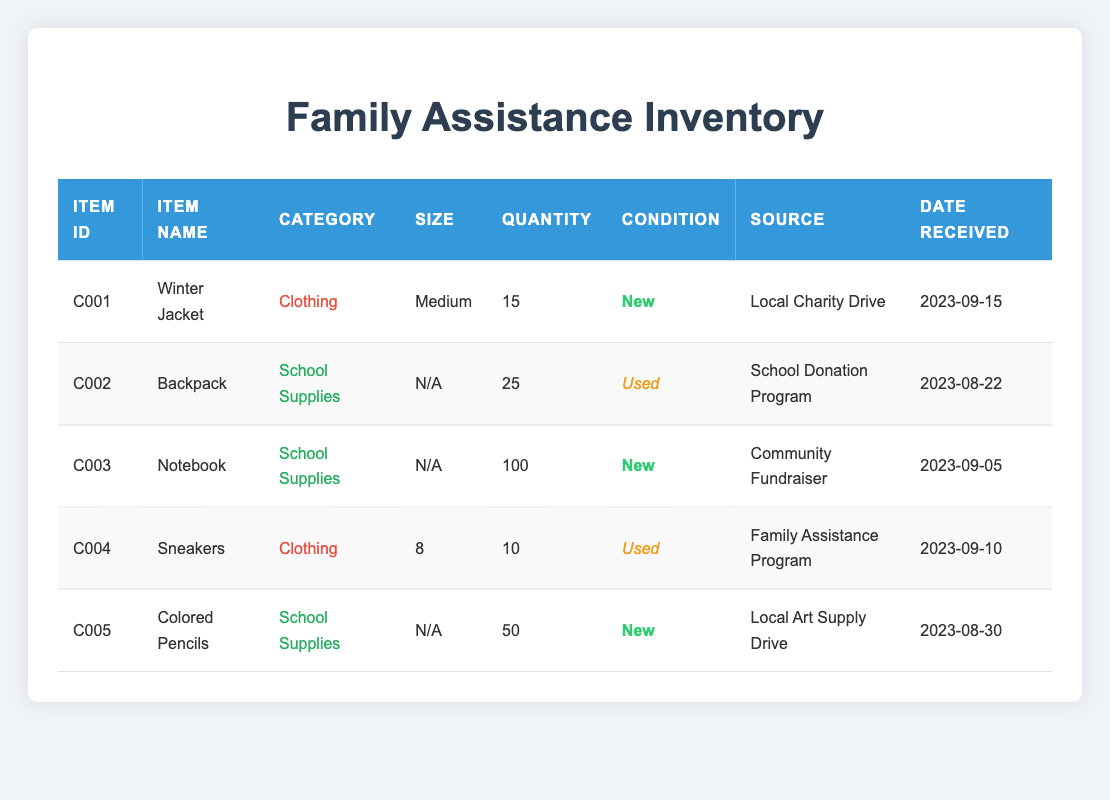What is the quantity of Winter Jackets received? The table lists the item 'Winter Jacket' with an item ID of C001, and in the quantity column for this item, it shows '15'.
Answer: 15 How many used items are in the inventory? The inventory contains two used items: 'Backpack' (C002) with a quantity of 25 and 'Sneakers' (C004) with a quantity of 10. Therefore, the total used items is 25 + 10 = 35.
Answer: 35 Which item has the largest quantity? By looking at the quantities listed, 'Notebook' (C003) has the highest quantity at 100. Thus, the item with the largest quantity is 'Notebook'.
Answer: Notebook Are there any items in good condition received from the Family Assistance Program? The 'Sneakers' (C004) is the only item listed from the 'Family Assistance Program', and it is marked as 'Used', which is not in good condition. Therefore, there are no items in good condition from this source.
Answer: No What is the total quantity of school supplies received? The school supplies in the inventory include 'Backpack' (C002) with 25, 'Notebook' (C003) with 100, and 'Colored Pencils' (C005) with 50. Adding these quantities gives: 25 + 100 + 50 = 175.
Answer: 175 Which source provided the most items? The three categories along with their total quantities are: 'School Donation Program' (Backpack) 25, 'Community Fundraiser' (Notebook) 100, and 'Local Art Supply Drive' (Colored Pencils) 50. The 'Community Fundraiser' gave the highest total of 100 items through 'Notebook'.
Answer: Community Fundraiser Is there a Winter Jacket in new condition? The 'Winter Jacket' (C001) is listed with the condition marked as 'New', confirming it is indeed in new condition.
Answer: Yes What is the average quantity of clothing items received? The clothing items are 'Winter Jacket' (C001) with 15 and 'Sneakers' (C004) with 10. Adding these gives 15 + 10 = 25. There are 2 clothing items, so the average quantity is 25 / 2 = 12.5.
Answer: 12.5 How many items were received on or after September 10, 2023? Checking the date received for each item, 'Sneakers' (C004) on 2023-09-10, 'Winter Jacket' (C001) on 2023-09-15 qualify. There are 2 items received on or after this date.
Answer: 2 